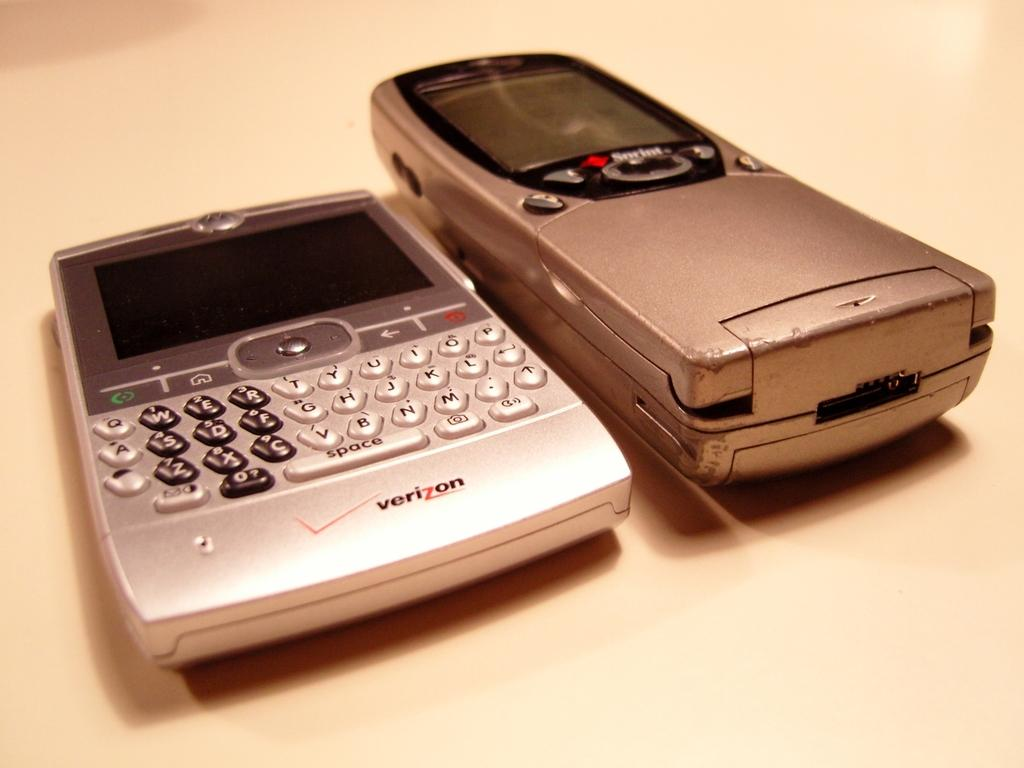<image>
Create a compact narrative representing the image presented. A silver-gray electronic device is made by Verizon. 